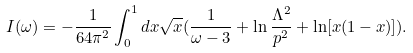Convert formula to latex. <formula><loc_0><loc_0><loc_500><loc_500>I ( \omega ) = - \frac { 1 } { 6 4 \pi ^ { 2 } } \int _ { 0 } ^ { 1 } d x \sqrt { x } ( \frac { 1 } { \omega - 3 } + \ln \frac { \Lambda ^ { 2 } } { p ^ { 2 } } + \ln [ x ( 1 - x ) ] ) .</formula> 